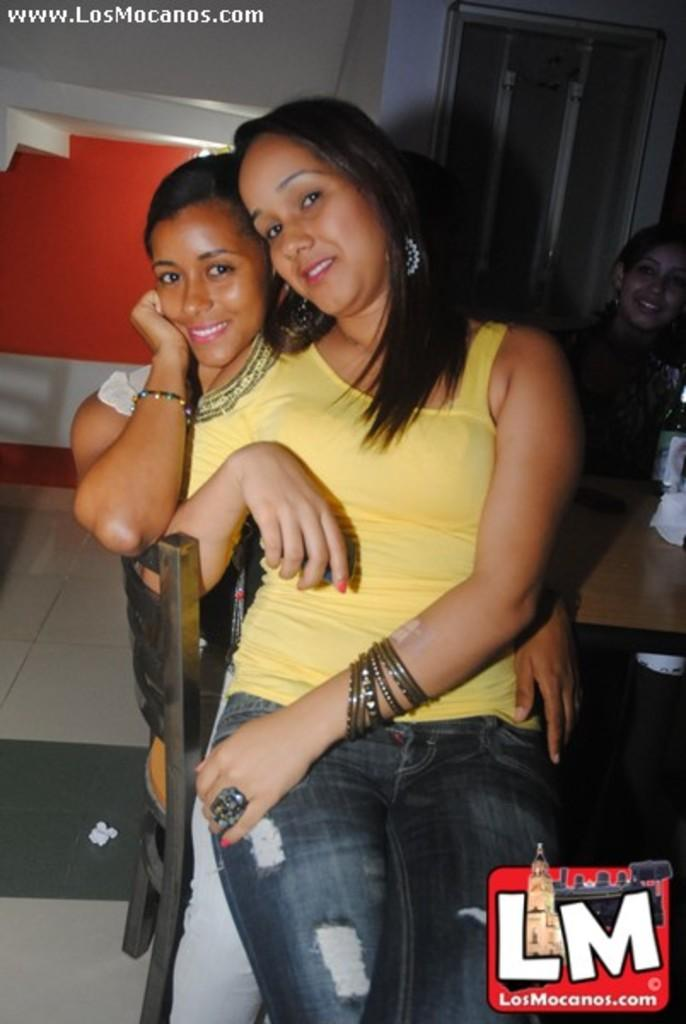How many people are in the image? There are two girls in the image. What are the girls doing in the image? The girls are sitting on a chair. How are the girls positioned on the chair? The girls are sitting one above the other. What is located beside the chair in the image? There is a table beside the chair. What type of wound can be seen on the girls' hands in the image? There are no visible wounds on the girls' hands in the image. What is the girls' desire in the image? The image does not provide information about the girls' desires, so we cannot determine their desires from the image. 